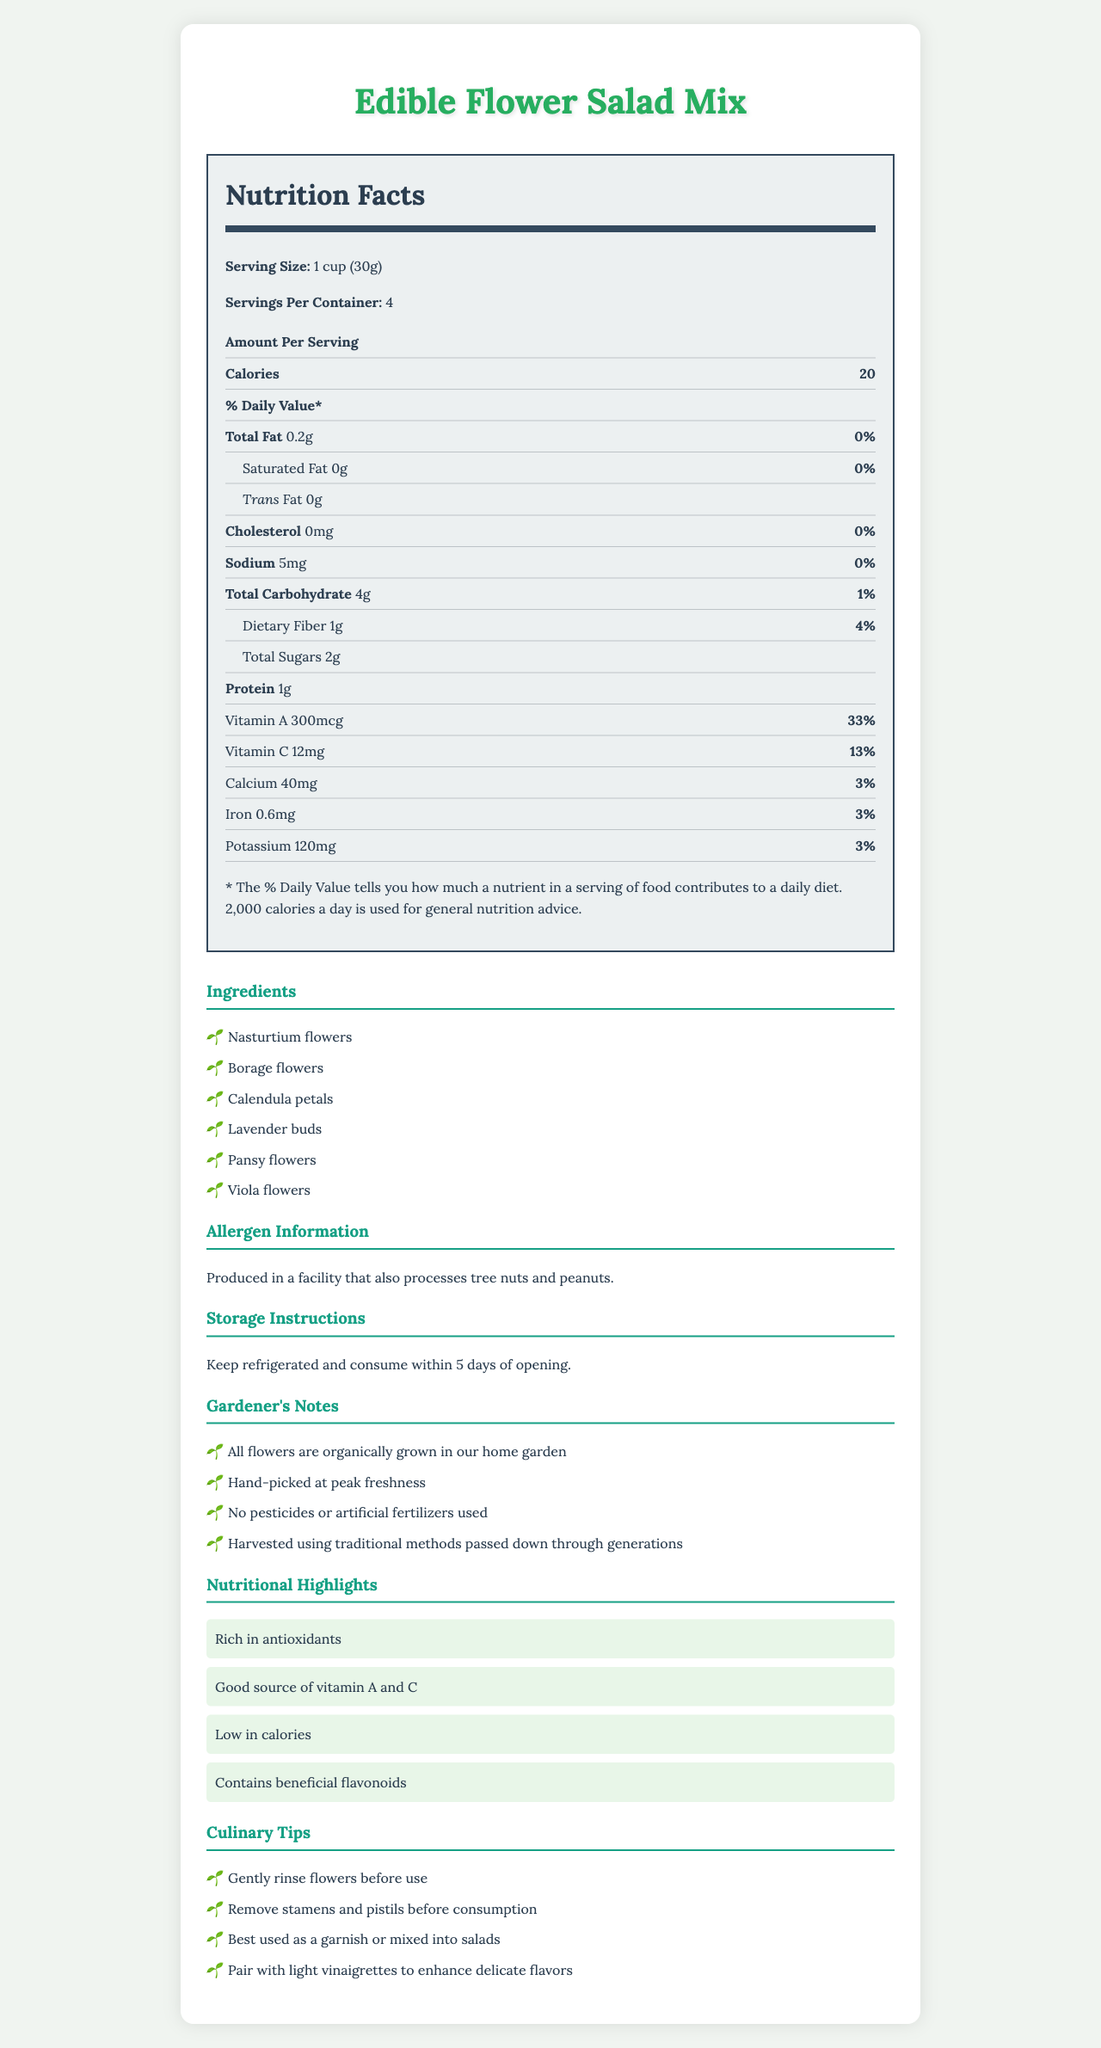what is the serving size for the Edible Flower Salad Mix? The serving size is clearly stated as "1 cup (30g)" in the nutrition facts section.
Answer: 1 cup (30g) how many calories are in one serving of the Edible Flower Salad Mix? The nutrition facts section states that one serving contains 20 calories.
Answer: 20 calories what is the amount of protein per serving? The table in the nutrition facts section specifies that one serving contains 1g of protein.
Answer: 1g how much Vitamin C is in one serving, and what percentage of the daily value does it provide? The nutrition facts list Vitamin C as 12mg per serving, which is 13% of the daily value.
Answer: 12mg, 13% list the edible flowers included in the ingredients. The ingredients section lists these flowers as the components of the salad mix.
Answer: Nasturtium flowers, Borage flowers, Calendula petals, Lavender buds, Pansy flowers, Viola flowers how much total carbohydrate is in one serving? The nutrition facts section lists the total carbohydrate content as 4g per serving.
Answer: 4g does this product contain any trans fat? The nutrition facts label states that the product contains 0g of trans fat.
Answer: No what are the gardener's notes mentioned in the document? The gardener's notes section provides these details.
Answer: All flowers are organically grown in our home garden, Hand-picked at peak freshness, No pesticides or artificial fertilizers used, Harvested using traditional methods passed down through generations how should the Edible Flower Salad Mix be stored? The storage instructions section gives these details.
Answer: Keep refrigerated and consume within 5 days of opening which vitamins are highlighted as nutritional benefits in the document? The nutritional highlights section mentions these vitamins.
Answer: Vitamin A and Vitamin C what is the amount of calcium per serving, and what percentage of the daily value does it provide? The nutrition facts list calcium as 40mg per serving, which is 3% of the daily value.
Answer: 40mg, 3% which of the following ingredients is not part of the Edible Flower Salad Mix? A. Lavender buds B. Nasturtium flowers C. Rose petals D. Pansy flowers The ingredients section lists Lavender buds, Nasturtium flowers, and Pansy flowers, but not Rose petals.
Answer: C which of the following best describes the nutritional highlights of this product? A. Low in fat and high in protein B. Low in calories and rich in antioxidants C. High in calories and low in sugars D. High in sodium and low in vitamins The nutritional highlights section mentions that the product is low in calories and rich in antioxidants.
Answer: B is the product free of cholesterol? The nutrition facts label indicates there is 0mg of cholesterol per serving.
Answer: Yes summarize the main attributes described in the document for the Edible Flower Salad Mix. The document comprehensively describes the nutritional, ingredient, storage, and gardening details for the Edible Flower Salad Mix, highlighting its benefits, cultivation methods, and use instructions.
Answer: The Edible Flower Salad Mix offers a low-calorie and nutritious option with a mix of organically grown edible flowers. The nutrition facts label provides detailed information on its low fat, carbohydrate, and high vitamin A and C contents. Important storage, allergen information, and culinary tips are provided alongside the gardener's notes emphasizing organic and traditional gardening practices. what is the specific source of the iron content in this product? The document does not specify which ingredient(s) are the source of iron content in this product.
Answer: Not enough information 